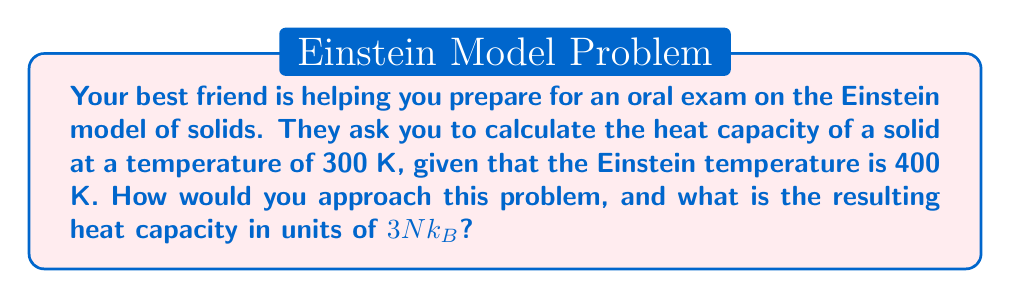Can you answer this question? To solve this problem, let's follow these steps:

1) The Einstein model gives the heat capacity $C_V$ as:

   $$C_V = 3Nk_B \left(\frac{\Theta_E}{T}\right)^2 \frac{e^{\Theta_E/T}}{(e^{\Theta_E/T}-1)^2}$$

   where $N$ is the number of atoms, $k_B$ is the Boltzmann constant, $\Theta_E$ is the Einstein temperature, and $T$ is the temperature.

2) We're given:
   $T = 300$ K
   $\Theta_E = 400$ K

3) Let's define $x = \Theta_E/T$:

   $$x = \frac{400 \text{ K}}{300 \text{ K}} = \frac{4}{3}$$

4) Now we can rewrite the heat capacity equation:

   $$C_V = 3Nk_B \cdot x^2 \frac{e^x}{(e^x-1)^2}$$

5) Substituting $x = 4/3$:

   $$C_V = 3Nk_B \cdot \left(\frac{4}{3}\right)^2 \frac{e^{4/3}}{(e^{4/3}-1)^2}$$

6) Calculate $e^{4/3} \approx 3.7956$

7) Plugging this in:

   $$C_V = 3Nk_B \cdot \frac{16}{9} \frac{3.7956}{(3.7956-1)^2} \approx 3Nk_B \cdot 0.9301$$

Thus, the heat capacity is approximately 0.9301 in units of $3Nk_B$.
Answer: $0.9301 \cdot 3Nk_B$ 